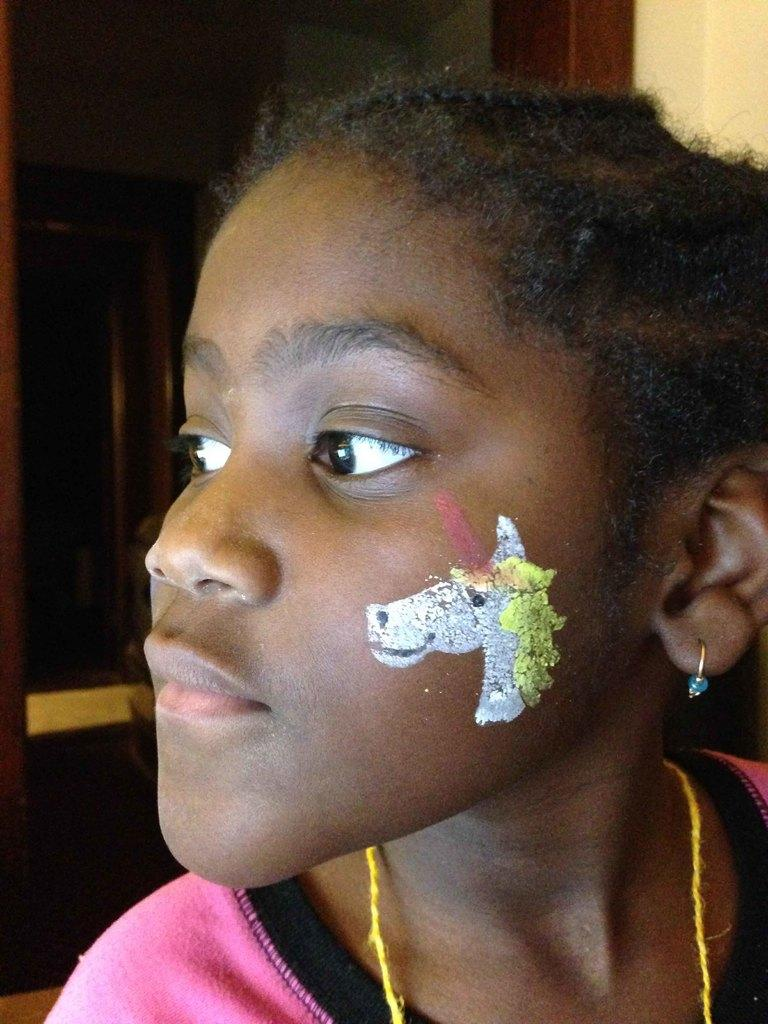What is depicted on the girl's cheek in the image? There is a painting of a unicorn on a girl's cheek. What can be seen in the background of the image? There is a door and a wall visible in the background. Can you see any geese flying near the icicle in the image? There is no mention of geese or icicles in the image; it features a painting of a unicorn on a girl's cheek and a door and wall in the background. 